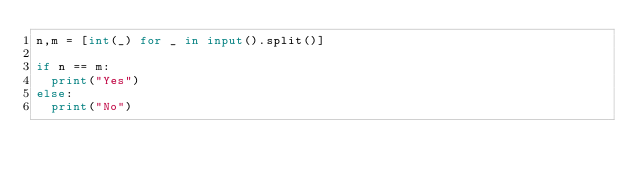<code> <loc_0><loc_0><loc_500><loc_500><_Python_>n,m = [int(_) for _ in input().split()]

if n == m:
  print("Yes")
else:
  print("No")</code> 